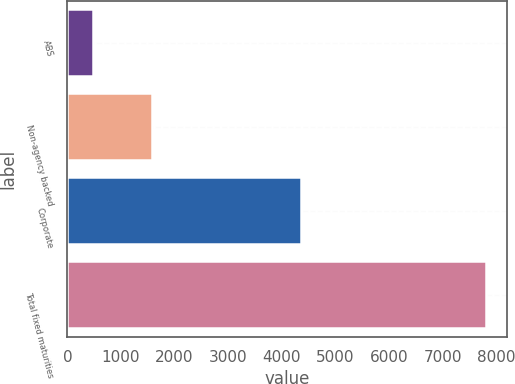Convert chart. <chart><loc_0><loc_0><loc_500><loc_500><bar_chart><fcel>ABS<fcel>Non-agency backed<fcel>Corporate<fcel>Total fixed maturities<nl><fcel>478<fcel>1572<fcel>4353<fcel>7819<nl></chart> 